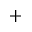<formula> <loc_0><loc_0><loc_500><loc_500>^ { + }</formula> 